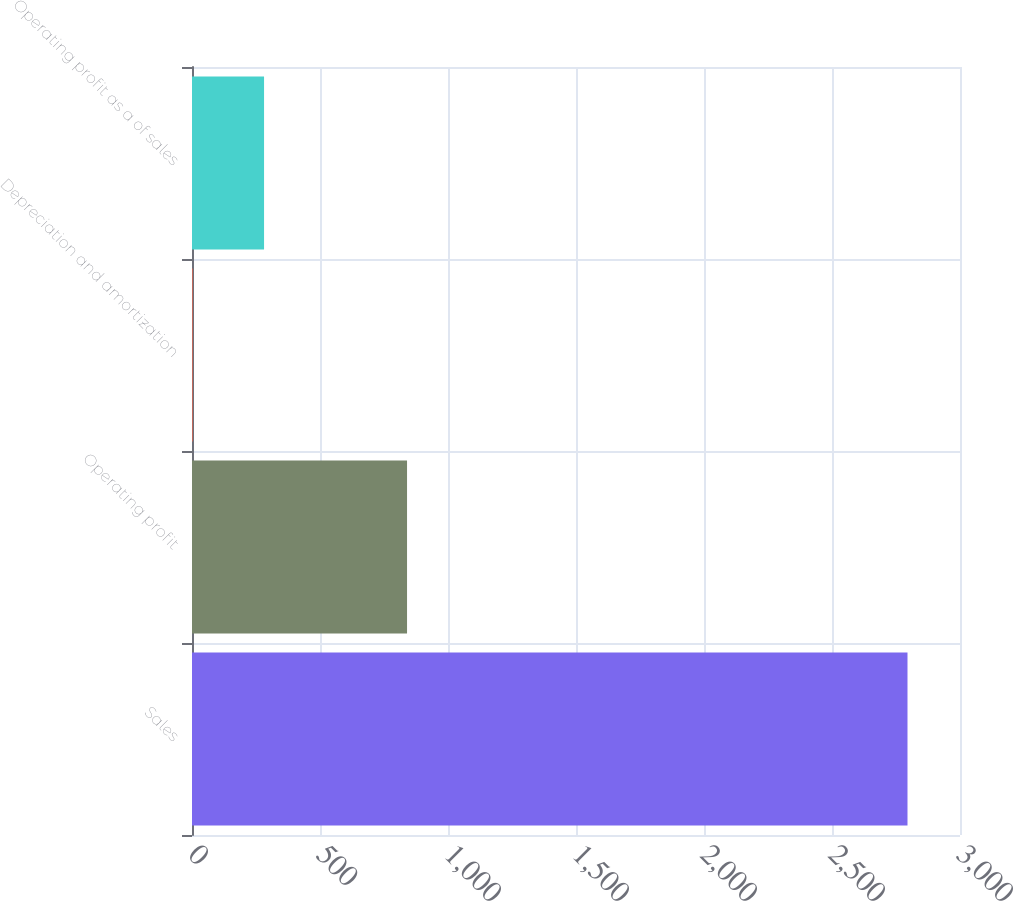Convert chart. <chart><loc_0><loc_0><loc_500><loc_500><bar_chart><fcel>Sales<fcel>Operating profit<fcel>Depreciation and amortization<fcel>Operating profit as a of sales<nl><fcel>2794.9<fcel>840.01<fcel>2.2<fcel>281.47<nl></chart> 